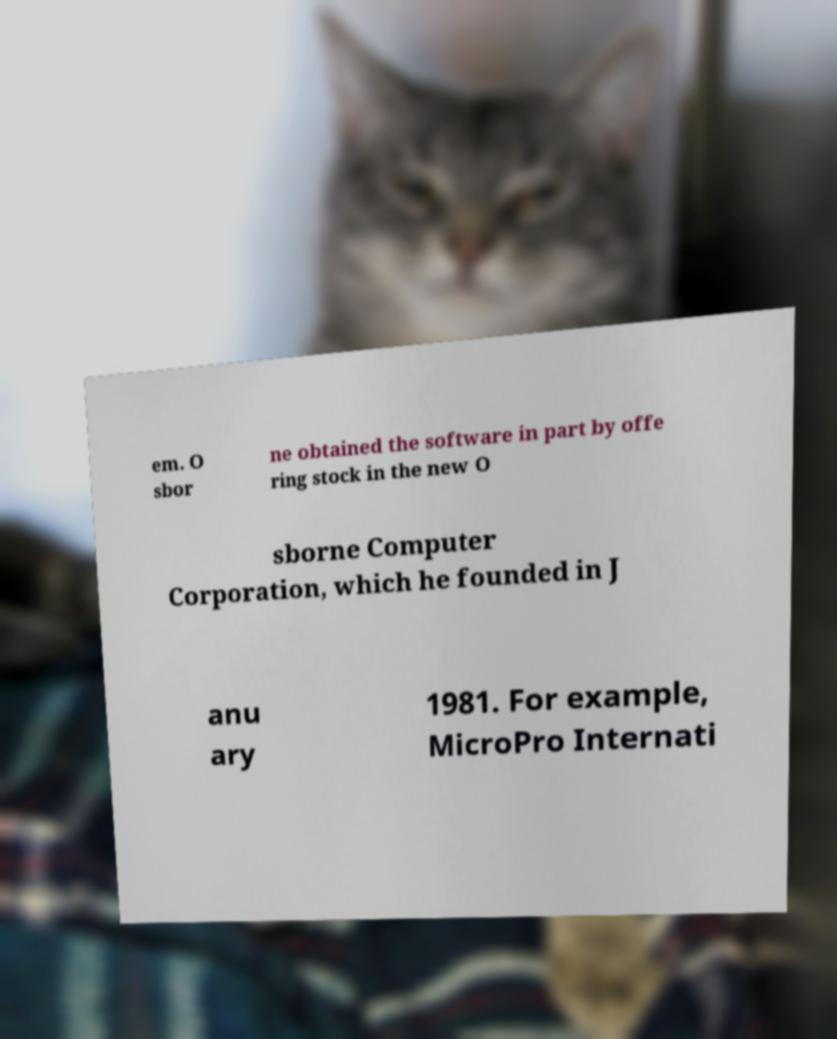Can you read and provide the text displayed in the image?This photo seems to have some interesting text. Can you extract and type it out for me? em. O sbor ne obtained the software in part by offe ring stock in the new O sborne Computer Corporation, which he founded in J anu ary 1981. For example, MicroPro Internati 